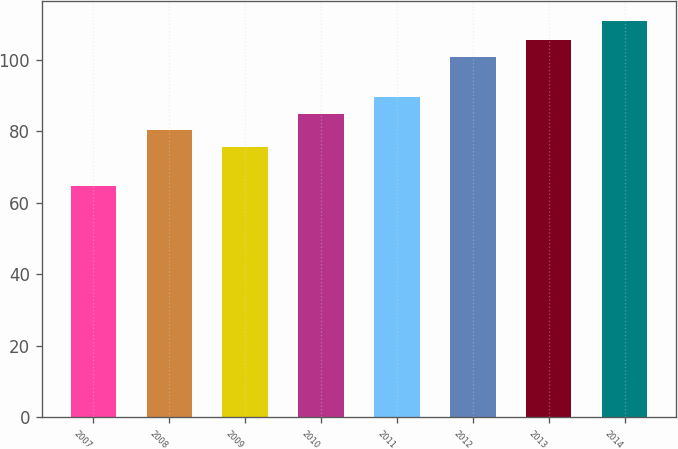Convert chart to OTSL. <chart><loc_0><loc_0><loc_500><loc_500><bar_chart><fcel>2007<fcel>2008<fcel>2009<fcel>2010<fcel>2011<fcel>2012<fcel>2013<fcel>2014<nl><fcel>64.6<fcel>80.33<fcel>75.7<fcel>84.96<fcel>89.59<fcel>100.9<fcel>105.53<fcel>110.9<nl></chart> 